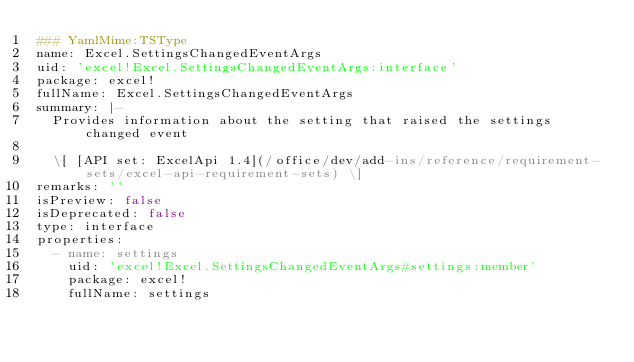Convert code to text. <code><loc_0><loc_0><loc_500><loc_500><_YAML_>### YamlMime:TSType
name: Excel.SettingsChangedEventArgs
uid: 'excel!Excel.SettingsChangedEventArgs:interface'
package: excel!
fullName: Excel.SettingsChangedEventArgs
summary: |-
  Provides information about the setting that raised the settings changed event

  \[ [API set: ExcelApi 1.4](/office/dev/add-ins/reference/requirement-sets/excel-api-requirement-sets) \]
remarks: ''
isPreview: false
isDeprecated: false
type: interface
properties:
  - name: settings
    uid: 'excel!Excel.SettingsChangedEventArgs#settings:member'
    package: excel!
    fullName: settings</code> 